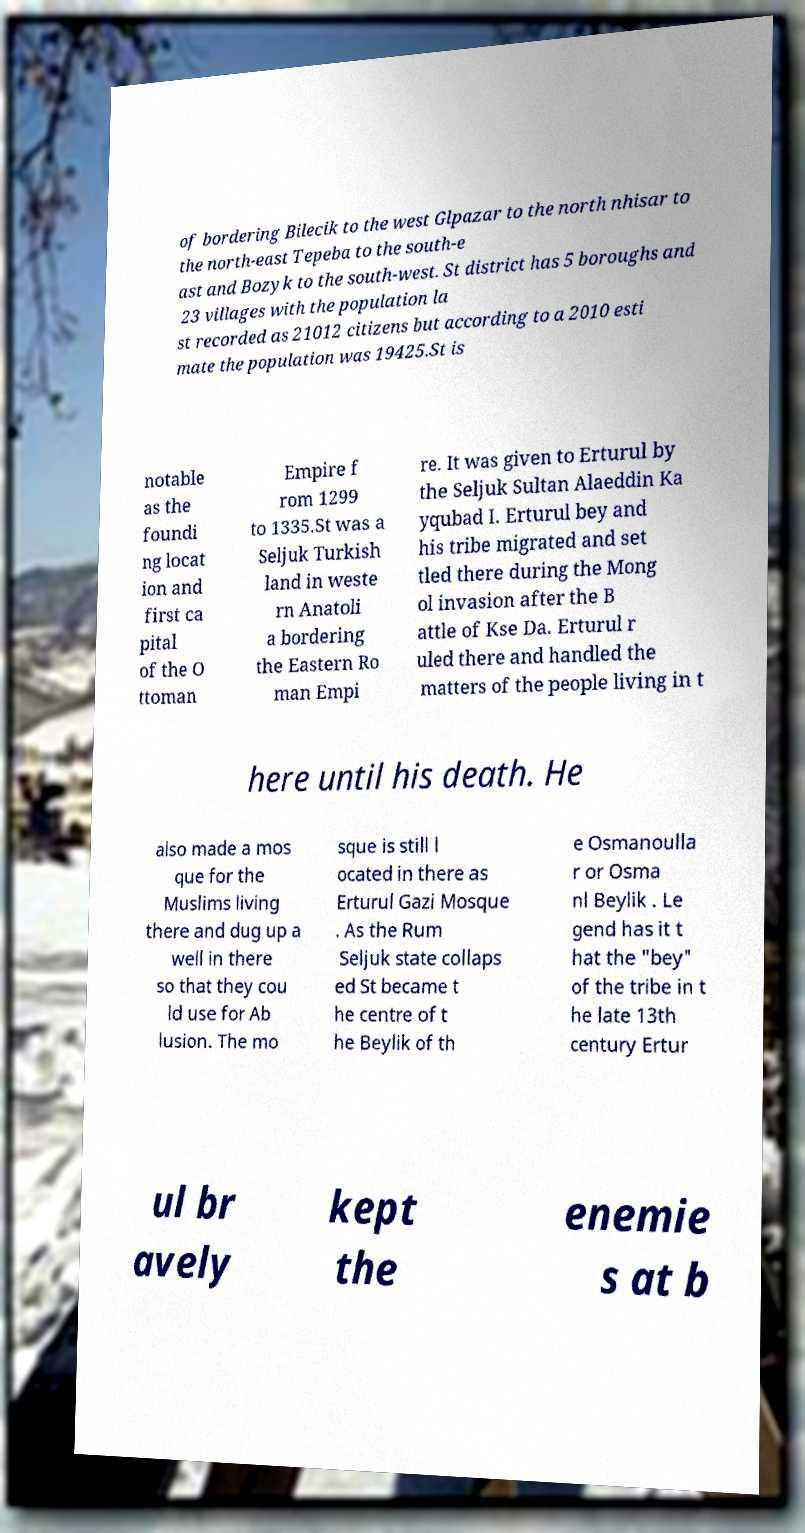Could you assist in decoding the text presented in this image and type it out clearly? of bordering Bilecik to the west Glpazar to the north nhisar to the north-east Tepeba to the south-e ast and Bozyk to the south-west. St district has 5 boroughs and 23 villages with the population la st recorded as 21012 citizens but according to a 2010 esti mate the population was 19425.St is notable as the foundi ng locat ion and first ca pital of the O ttoman Empire f rom 1299 to 1335.St was a Seljuk Turkish land in weste rn Anatoli a bordering the Eastern Ro man Empi re. It was given to Erturul by the Seljuk Sultan Alaeddin Ka yqubad I. Erturul bey and his tribe migrated and set tled there during the Mong ol invasion after the B attle of Kse Da. Erturul r uled there and handled the matters of the people living in t here until his death. He also made a mos que for the Muslims living there and dug up a well in there so that they cou ld use for Ab lusion. The mo sque is still l ocated in there as Erturul Gazi Mosque . As the Rum Seljuk state collaps ed St became t he centre of t he Beylik of th e Osmanoulla r or Osma nl Beylik . Le gend has it t hat the "bey" of the tribe in t he late 13th century Ertur ul br avely kept the enemie s at b 